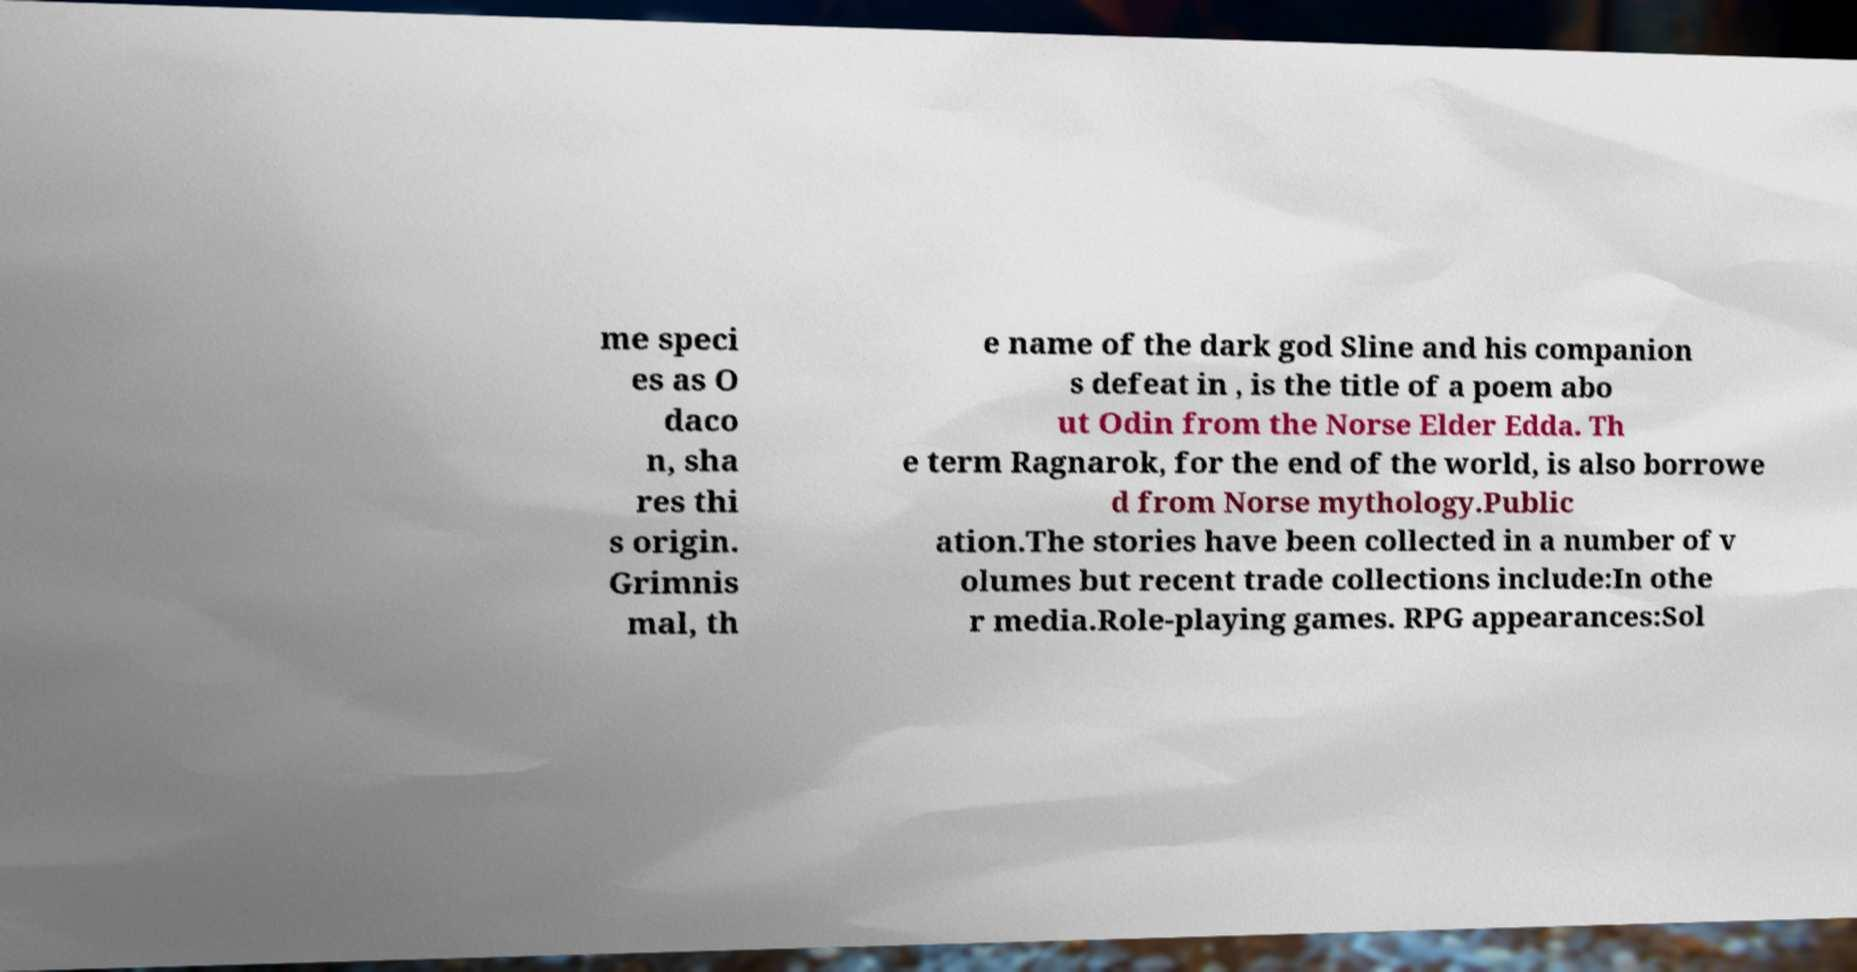Could you extract and type out the text from this image? me speci es as O daco n, sha res thi s origin. Grimnis mal, th e name of the dark god Sline and his companion s defeat in , is the title of a poem abo ut Odin from the Norse Elder Edda. Th e term Ragnarok, for the end of the world, is also borrowe d from Norse mythology.Public ation.The stories have been collected in a number of v olumes but recent trade collections include:In othe r media.Role-playing games. RPG appearances:Sol 